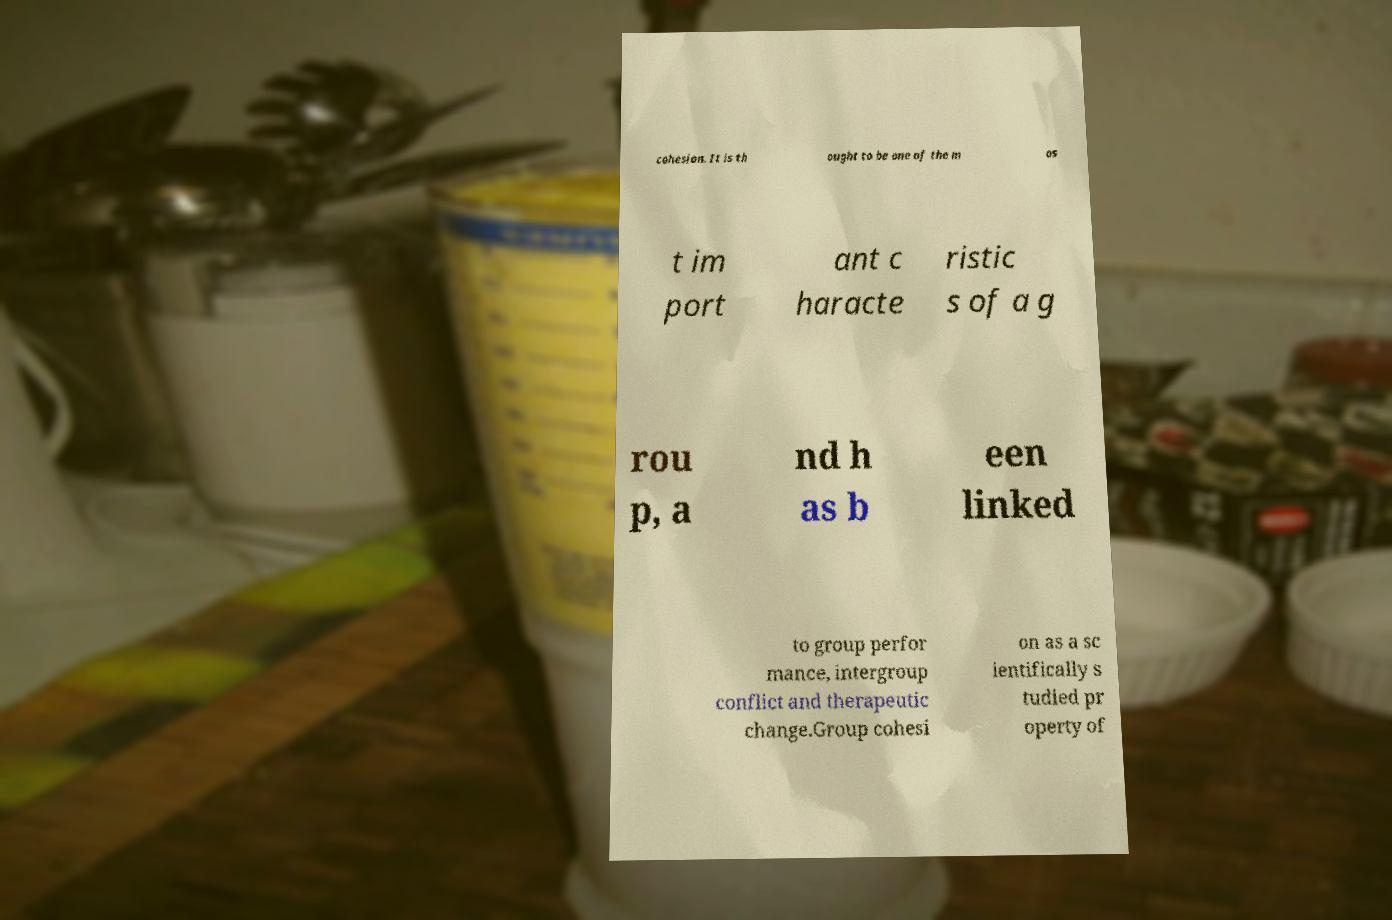Please read and relay the text visible in this image. What does it say? cohesion. It is th ought to be one of the m os t im port ant c haracte ristic s of a g rou p, a nd h as b een linked to group perfor mance, intergroup conflict and therapeutic change.Group cohesi on as a sc ientifically s tudied pr operty of 